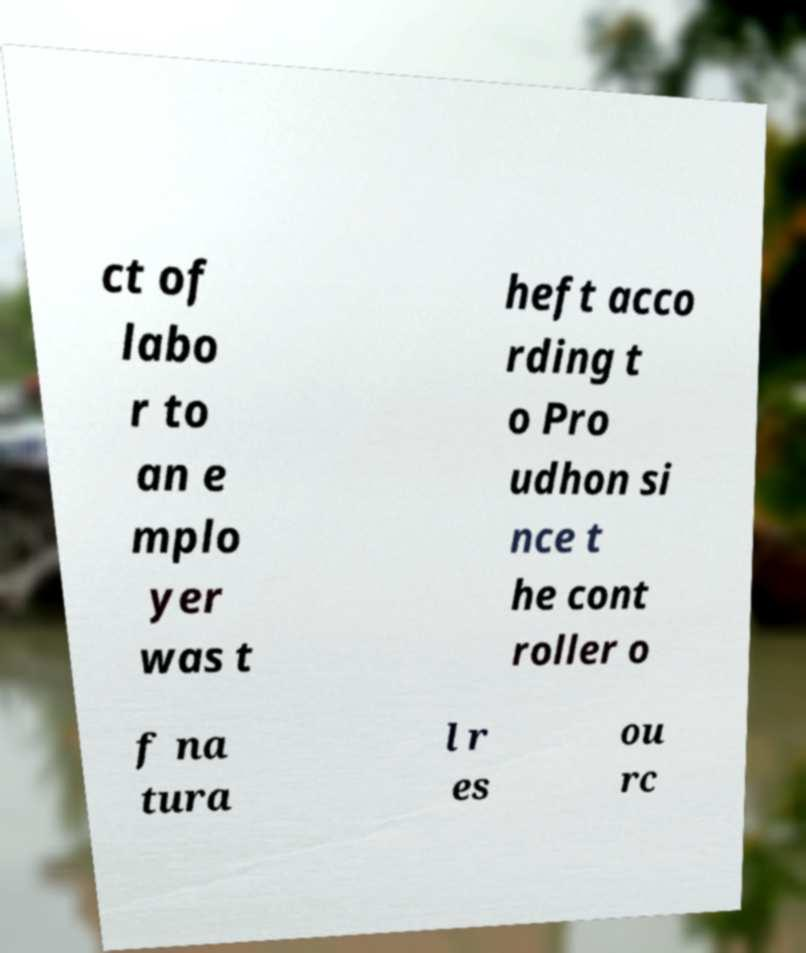Could you extract and type out the text from this image? ct of labo r to an e mplo yer was t heft acco rding t o Pro udhon si nce t he cont roller o f na tura l r es ou rc 